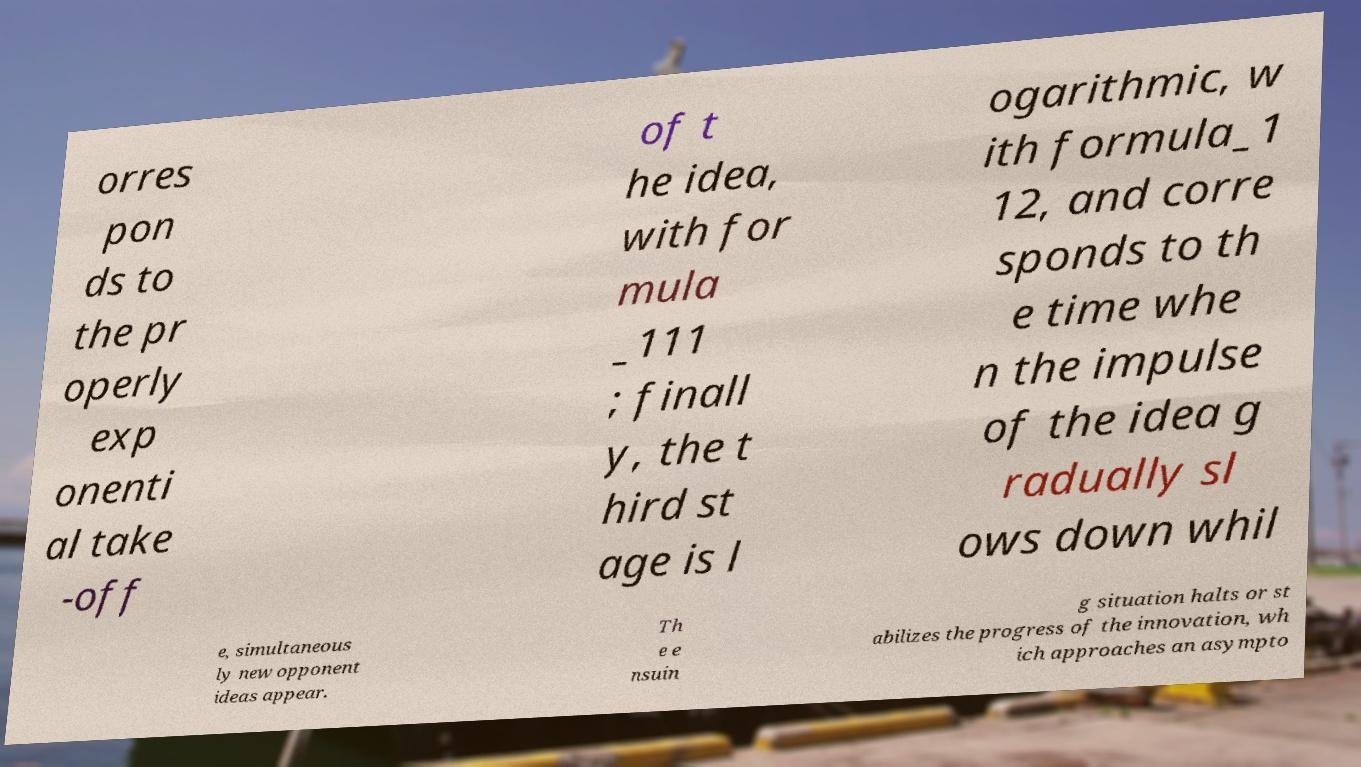I need the written content from this picture converted into text. Can you do that? orres pon ds to the pr operly exp onenti al take -off of t he idea, with for mula _111 ; finall y, the t hird st age is l ogarithmic, w ith formula_1 12, and corre sponds to th e time whe n the impulse of the idea g radually sl ows down whil e, simultaneous ly new opponent ideas appear. Th e e nsuin g situation halts or st abilizes the progress of the innovation, wh ich approaches an asympto 